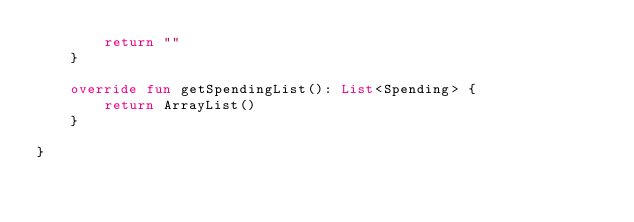<code> <loc_0><loc_0><loc_500><loc_500><_Kotlin_>        return ""
    }

    override fun getSpendingList(): List<Spending> {
        return ArrayList()
    }

}</code> 